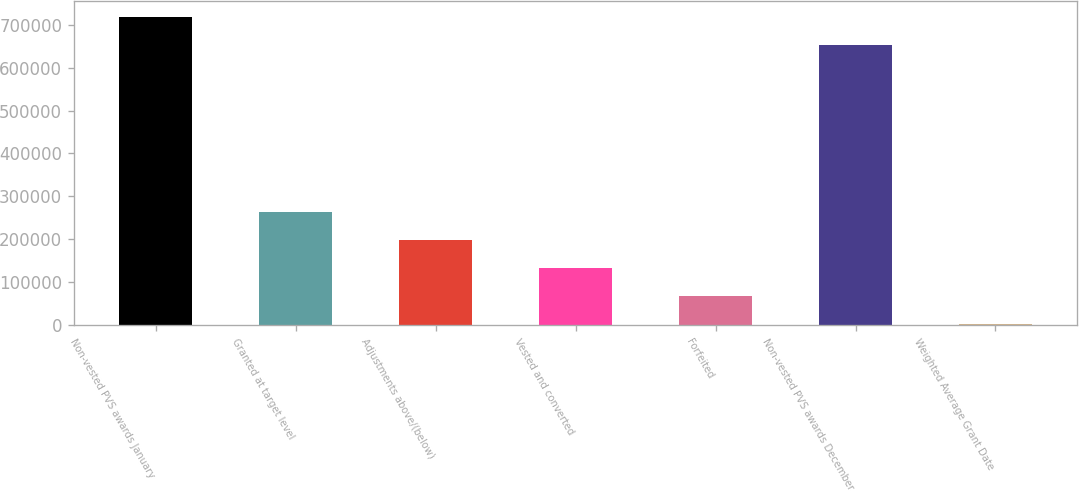Convert chart. <chart><loc_0><loc_0><loc_500><loc_500><bar_chart><fcel>Non-vested PVS awards January<fcel>Granted at target level<fcel>Adjustments above/(below)<fcel>Vested and converted<fcel>Forfeited<fcel>Non-vested PVS awards December<fcel>Weighted Average Grant Date<nl><fcel>718165<fcel>264022<fcel>198520<fcel>133017<fcel>67514.6<fcel>652662<fcel>2012<nl></chart> 